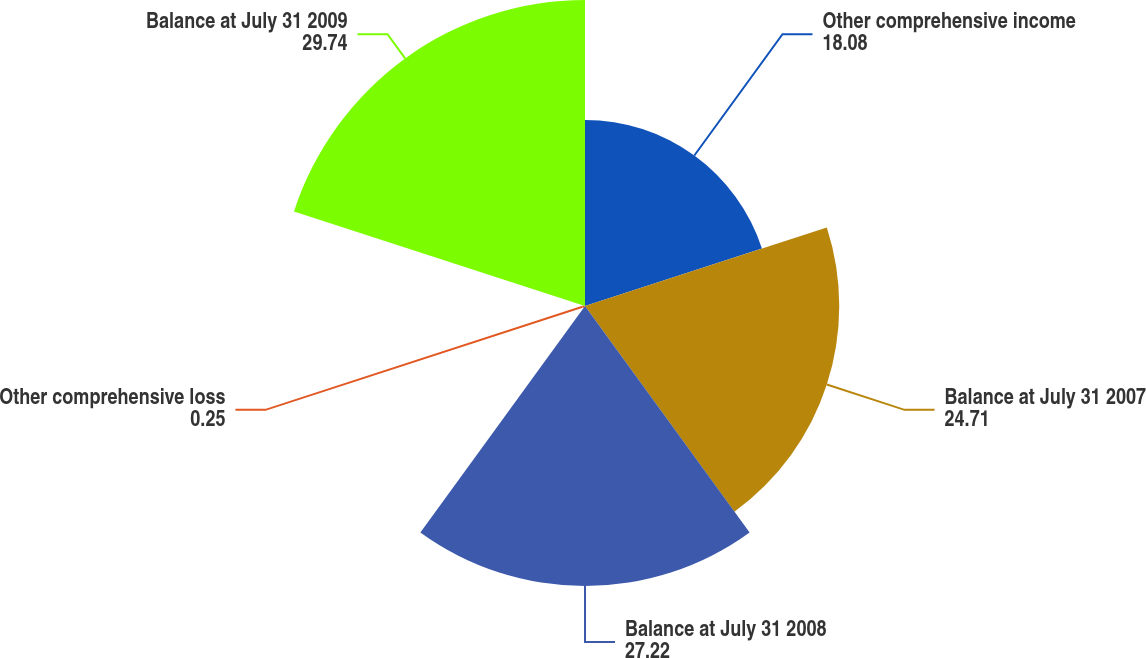Convert chart. <chart><loc_0><loc_0><loc_500><loc_500><pie_chart><fcel>Other comprehensive income<fcel>Balance at July 31 2007<fcel>Balance at July 31 2008<fcel>Other comprehensive loss<fcel>Balance at July 31 2009<nl><fcel>18.08%<fcel>24.71%<fcel>27.22%<fcel>0.25%<fcel>29.74%<nl></chart> 